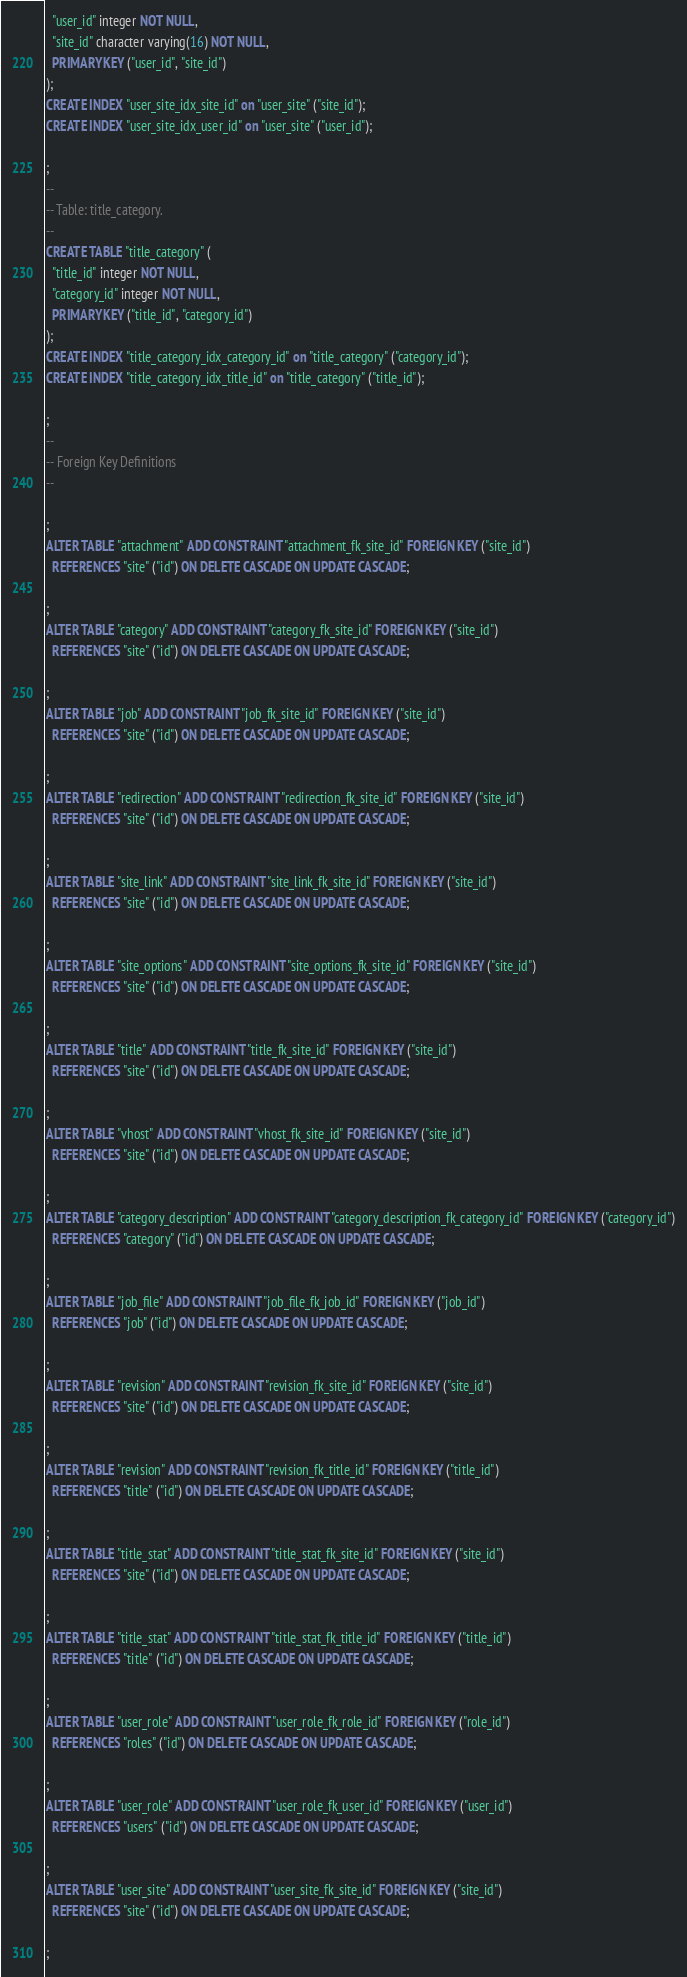Convert code to text. <code><loc_0><loc_0><loc_500><loc_500><_SQL_>  "user_id" integer NOT NULL,
  "site_id" character varying(16) NOT NULL,
  PRIMARY KEY ("user_id", "site_id")
);
CREATE INDEX "user_site_idx_site_id" on "user_site" ("site_id");
CREATE INDEX "user_site_idx_user_id" on "user_site" ("user_id");

;
--
-- Table: title_category.
--
CREATE TABLE "title_category" (
  "title_id" integer NOT NULL,
  "category_id" integer NOT NULL,
  PRIMARY KEY ("title_id", "category_id")
);
CREATE INDEX "title_category_idx_category_id" on "title_category" ("category_id");
CREATE INDEX "title_category_idx_title_id" on "title_category" ("title_id");

;
--
-- Foreign Key Definitions
--

;
ALTER TABLE "attachment" ADD CONSTRAINT "attachment_fk_site_id" FOREIGN KEY ("site_id")
  REFERENCES "site" ("id") ON DELETE CASCADE ON UPDATE CASCADE;

;
ALTER TABLE "category" ADD CONSTRAINT "category_fk_site_id" FOREIGN KEY ("site_id")
  REFERENCES "site" ("id") ON DELETE CASCADE ON UPDATE CASCADE;

;
ALTER TABLE "job" ADD CONSTRAINT "job_fk_site_id" FOREIGN KEY ("site_id")
  REFERENCES "site" ("id") ON DELETE CASCADE ON UPDATE CASCADE;

;
ALTER TABLE "redirection" ADD CONSTRAINT "redirection_fk_site_id" FOREIGN KEY ("site_id")
  REFERENCES "site" ("id") ON DELETE CASCADE ON UPDATE CASCADE;

;
ALTER TABLE "site_link" ADD CONSTRAINT "site_link_fk_site_id" FOREIGN KEY ("site_id")
  REFERENCES "site" ("id") ON DELETE CASCADE ON UPDATE CASCADE;

;
ALTER TABLE "site_options" ADD CONSTRAINT "site_options_fk_site_id" FOREIGN KEY ("site_id")
  REFERENCES "site" ("id") ON DELETE CASCADE ON UPDATE CASCADE;

;
ALTER TABLE "title" ADD CONSTRAINT "title_fk_site_id" FOREIGN KEY ("site_id")
  REFERENCES "site" ("id") ON DELETE CASCADE ON UPDATE CASCADE;

;
ALTER TABLE "vhost" ADD CONSTRAINT "vhost_fk_site_id" FOREIGN KEY ("site_id")
  REFERENCES "site" ("id") ON DELETE CASCADE ON UPDATE CASCADE;

;
ALTER TABLE "category_description" ADD CONSTRAINT "category_description_fk_category_id" FOREIGN KEY ("category_id")
  REFERENCES "category" ("id") ON DELETE CASCADE ON UPDATE CASCADE;

;
ALTER TABLE "job_file" ADD CONSTRAINT "job_file_fk_job_id" FOREIGN KEY ("job_id")
  REFERENCES "job" ("id") ON DELETE CASCADE ON UPDATE CASCADE;

;
ALTER TABLE "revision" ADD CONSTRAINT "revision_fk_site_id" FOREIGN KEY ("site_id")
  REFERENCES "site" ("id") ON DELETE CASCADE ON UPDATE CASCADE;

;
ALTER TABLE "revision" ADD CONSTRAINT "revision_fk_title_id" FOREIGN KEY ("title_id")
  REFERENCES "title" ("id") ON DELETE CASCADE ON UPDATE CASCADE;

;
ALTER TABLE "title_stat" ADD CONSTRAINT "title_stat_fk_site_id" FOREIGN KEY ("site_id")
  REFERENCES "site" ("id") ON DELETE CASCADE ON UPDATE CASCADE;

;
ALTER TABLE "title_stat" ADD CONSTRAINT "title_stat_fk_title_id" FOREIGN KEY ("title_id")
  REFERENCES "title" ("id") ON DELETE CASCADE ON UPDATE CASCADE;

;
ALTER TABLE "user_role" ADD CONSTRAINT "user_role_fk_role_id" FOREIGN KEY ("role_id")
  REFERENCES "roles" ("id") ON DELETE CASCADE ON UPDATE CASCADE;

;
ALTER TABLE "user_role" ADD CONSTRAINT "user_role_fk_user_id" FOREIGN KEY ("user_id")
  REFERENCES "users" ("id") ON DELETE CASCADE ON UPDATE CASCADE;

;
ALTER TABLE "user_site" ADD CONSTRAINT "user_site_fk_site_id" FOREIGN KEY ("site_id")
  REFERENCES "site" ("id") ON DELETE CASCADE ON UPDATE CASCADE;

;</code> 